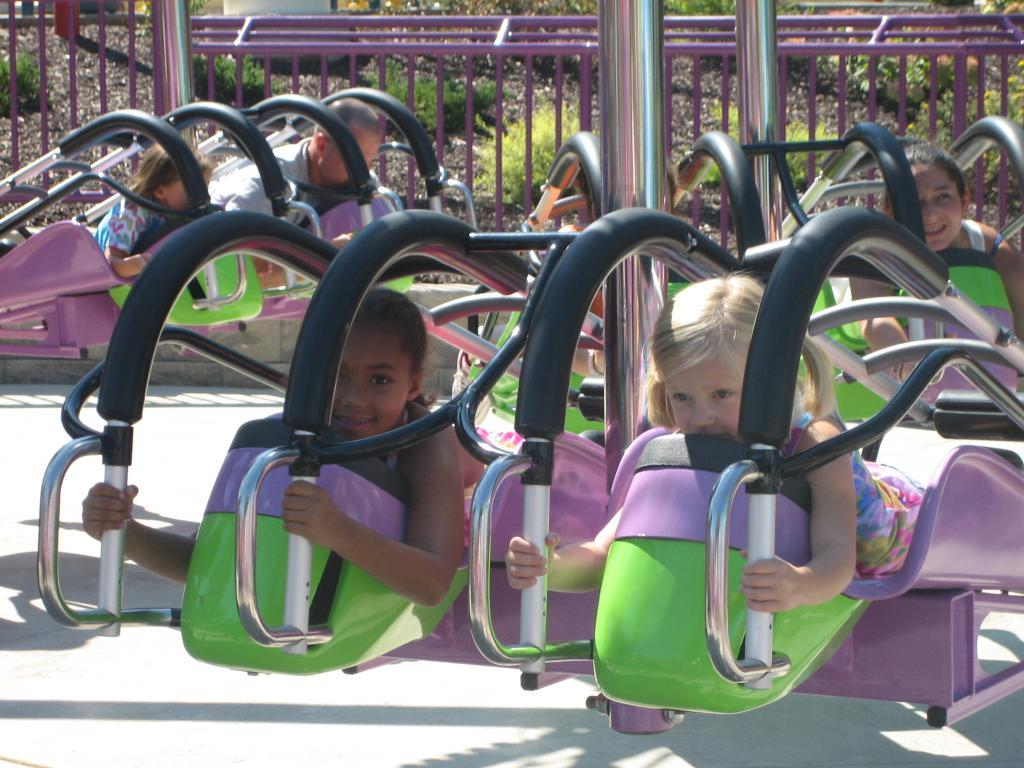What is the main subject of the image? There is an amusement park ride in the image. Are there any people interacting with the amusement park ride? Yes, there are people on the amusement park ride. What can be seen in the background of the image? There is a railing and plants on a path in the background of the image. What type of harmony is being played by the musicians in the image? There are no musicians or any indication of music in the image; it features an amusement park ride with people on it. What color is the sweater worn by the person in the image? There is no person wearing a sweater in the image; it only shows an amusement park ride and people on it. 